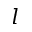Convert formula to latex. <formula><loc_0><loc_0><loc_500><loc_500>l</formula> 